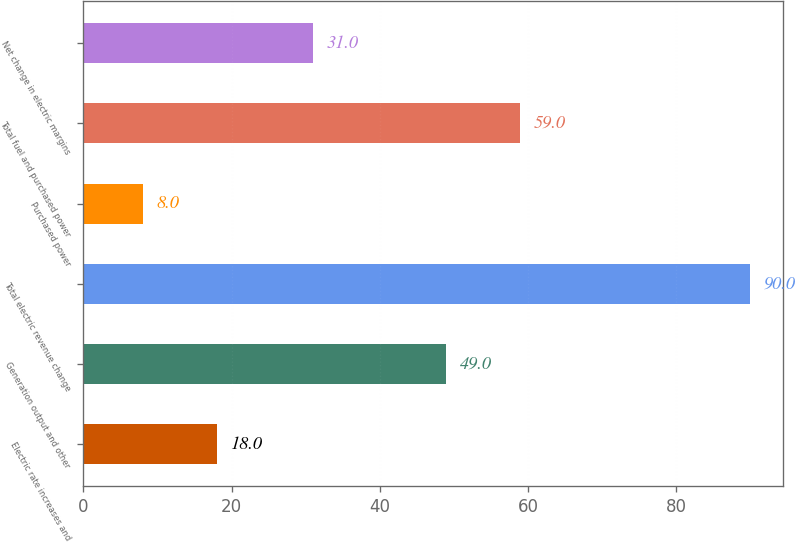Convert chart. <chart><loc_0><loc_0><loc_500><loc_500><bar_chart><fcel>Electric rate increases and<fcel>Generation output and other<fcel>Total electric revenue change<fcel>Purchased power<fcel>Total fuel and purchased power<fcel>Net change in electric margins<nl><fcel>18<fcel>49<fcel>90<fcel>8<fcel>59<fcel>31<nl></chart> 